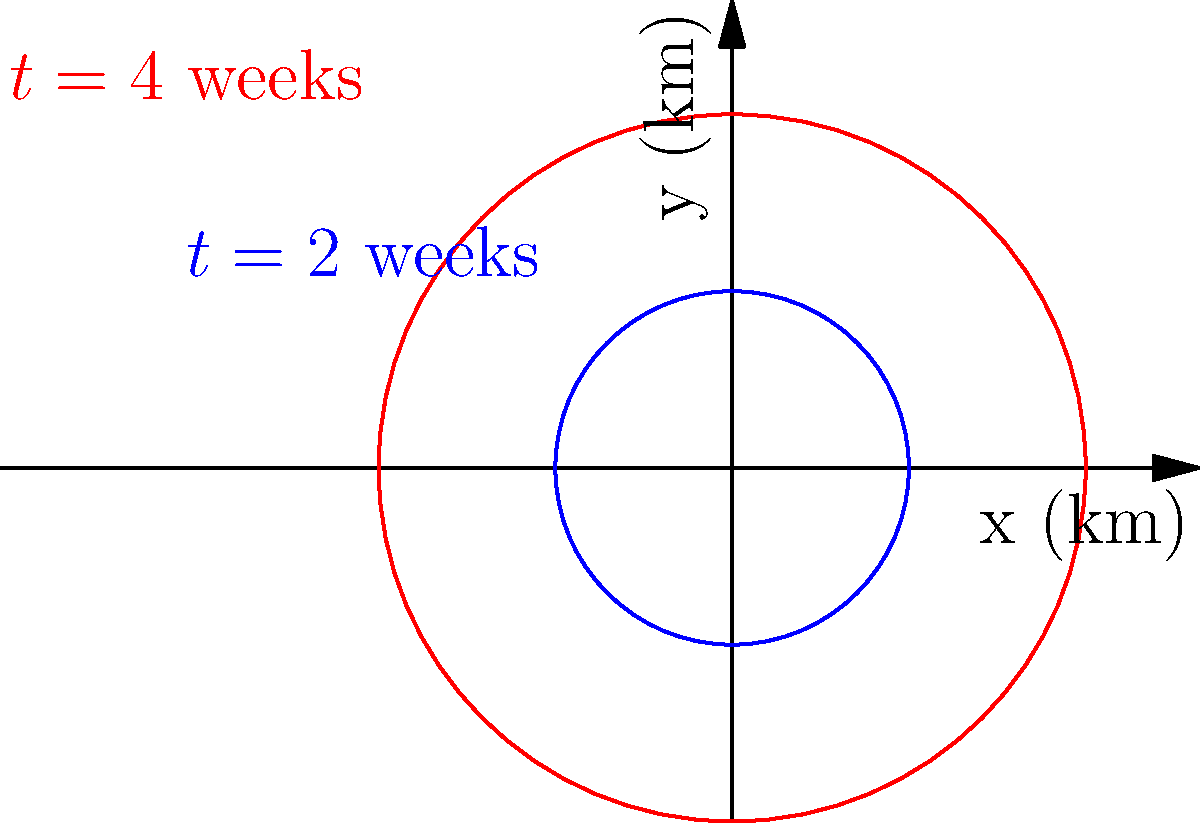A circular region representing the spread of a disease expands over time. The radius of the affected area grows linearly with time according to the function $r(t) = 1.5t$, where $r$ is the radius in kilometers and $t$ is the time in weeks. If the initial affected area at $t=2$ weeks is shown in blue, and the expanded area at $t=4$ weeks is shown in red, calculate the increase in the affected area (in square kilometers) between these two time points. To solve this problem, we'll follow these steps:

1) First, let's calculate the radii at $t=2$ and $t=4$ weeks:
   At $t=2$: $r(2) = 1.5 \cdot 2 = 3$ km
   At $t=4$: $r(4) = 1.5 \cdot 4 = 6$ km

2) Now, we can calculate the areas at these two time points using the formula $A = \pi r^2$:
   At $t=2$: $A_1 = \pi (3)^2 = 9\pi$ sq km
   At $t=4$: $A_2 = \pi (6)^2 = 36\pi$ sq km

3) The increase in area is the difference between these two areas:
   $\Delta A = A_2 - A_1 = 36\pi - 9\pi = 27\pi$ sq km

4) To get the numerical value, we can use $\pi \approx 3.14159$:
   $\Delta A \approx 27 \cdot 3.14159 \approx 84.82$ sq km

Therefore, the increase in the affected area between $t=2$ and $t=4$ weeks is approximately 84.82 square kilometers.
Answer: $27\pi$ sq km (or approximately 84.82 sq km) 